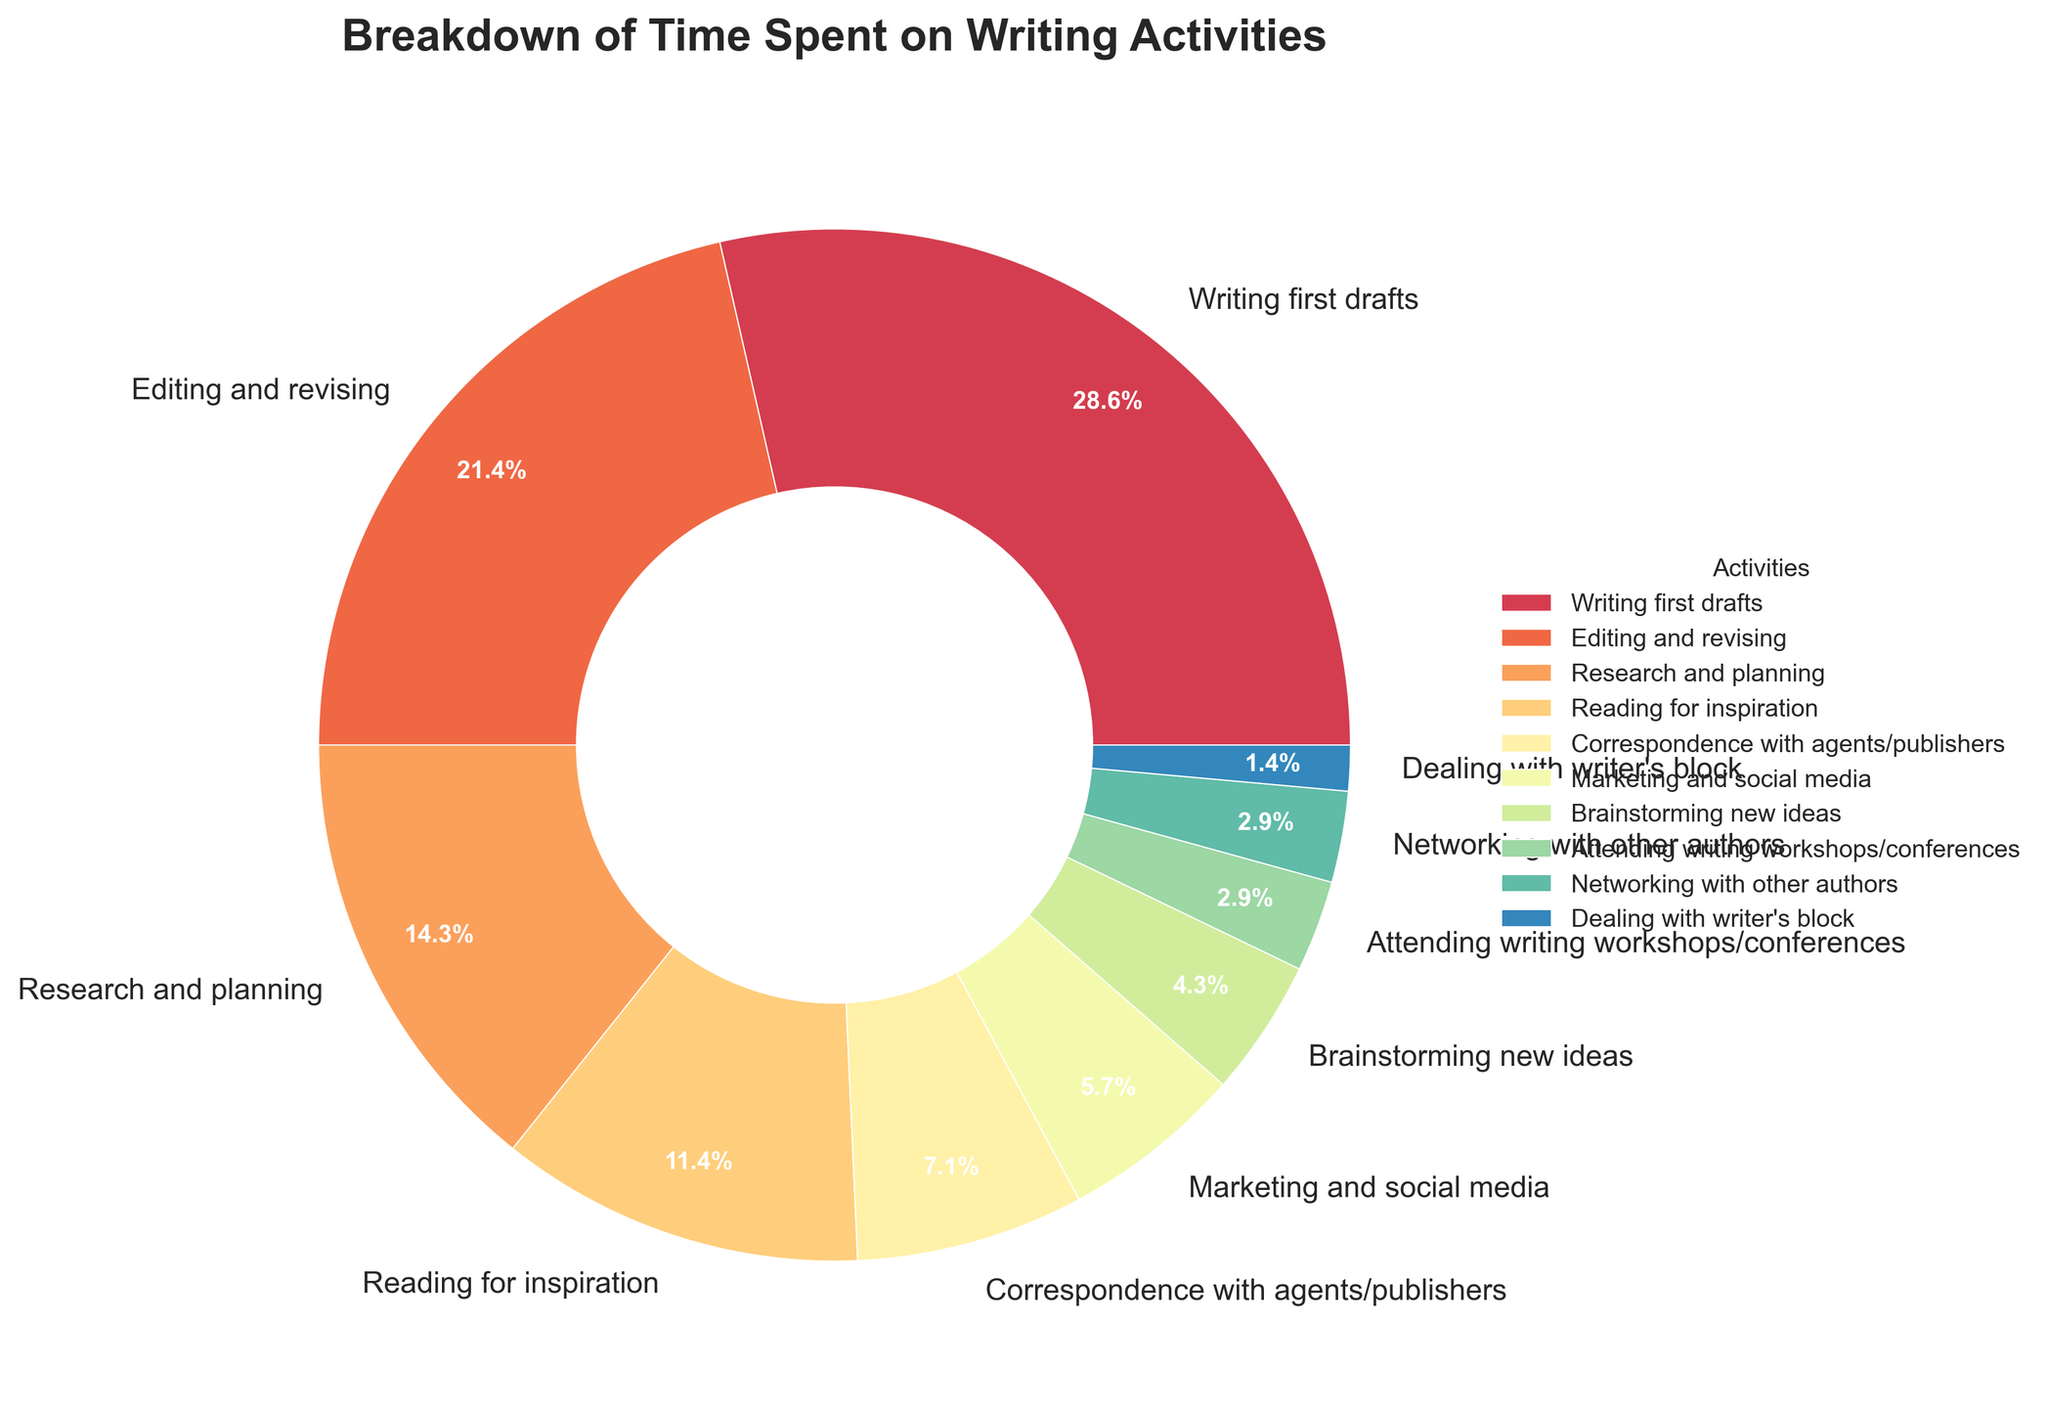How many more hours are spent on writing first drafts compared to dealing with writer's block? Writing first drafts takes 20 hours per week, while dealing with writer's block takes 1 hour per week. The difference is 20 - 1 = 19 hours.
Answer: 19 hours Which activity takes up the least amount of time? By examining the chart, dealing with writer's block is allocated the least amount of time at 1 hour per week.
Answer: Dealing with writer's block What percentage of time is spent on marketing and social media compared to writing first drafts? Marketing and social media take 4 hours per week, and writing first drafts take 20 hours per week. The percentage is calculated as (4 / 20) * 100 = 20%.
Answer: 20% Are more hours spent on research and planning or on reading for inspiration? Research and planning takes 10 hours per week, while reading for inspiration takes 8 hours per week. Therefore, more hours are spent on research and planning.
Answer: Research and planning How many total hours are spent on editing and revising, and correspondence with agents/publishers combined? Editing and revising takes 15 hours per week, and correspondence with agents/publishers takes 5 hours per week. Combined, these activities take 15 + 5 = 20 hours per week.
Answer: 20 hours What is the sum of hours spent on brainstorming new ideas and attending writing workshops/conferences? Brainstorming new ideas takes 3 hours per week, and attending writing workshops/conferences takes 2 hours per week. The sum is 3 + 2 = 5 hours per week.
Answer: 5 hours How does the time spent on editing and revising compare to the time spent on research and planning? Editing and revising takes 15 hours per week, while research and planning takes 10 hours per week, making editing and revising greater by 5 hours.
Answer: 5 hours more In terms of visual representation, which activity is associated with the largest wedge in the pie chart? The largest wedge in the pie chart is associated with writing first drafts, as it occupies the most substantial portion of the pie chart.
Answer: Writing first drafts Which activities (if any) have equal time allocations per week? Attending writing workshops/conferences and networking with other authors both take 2 hours per week, making them equal in time allocation.
Answer: Attending writing workshops/conferences and networking with other authors What is the total time spent on all writing activities combined? Summing all the hours spent on different activities: 20 + 15 + 10 + 8 + 5 + 4 + 3 + 2 + 2 + 1 = 70 hours per week.
Answer: 70 hours 